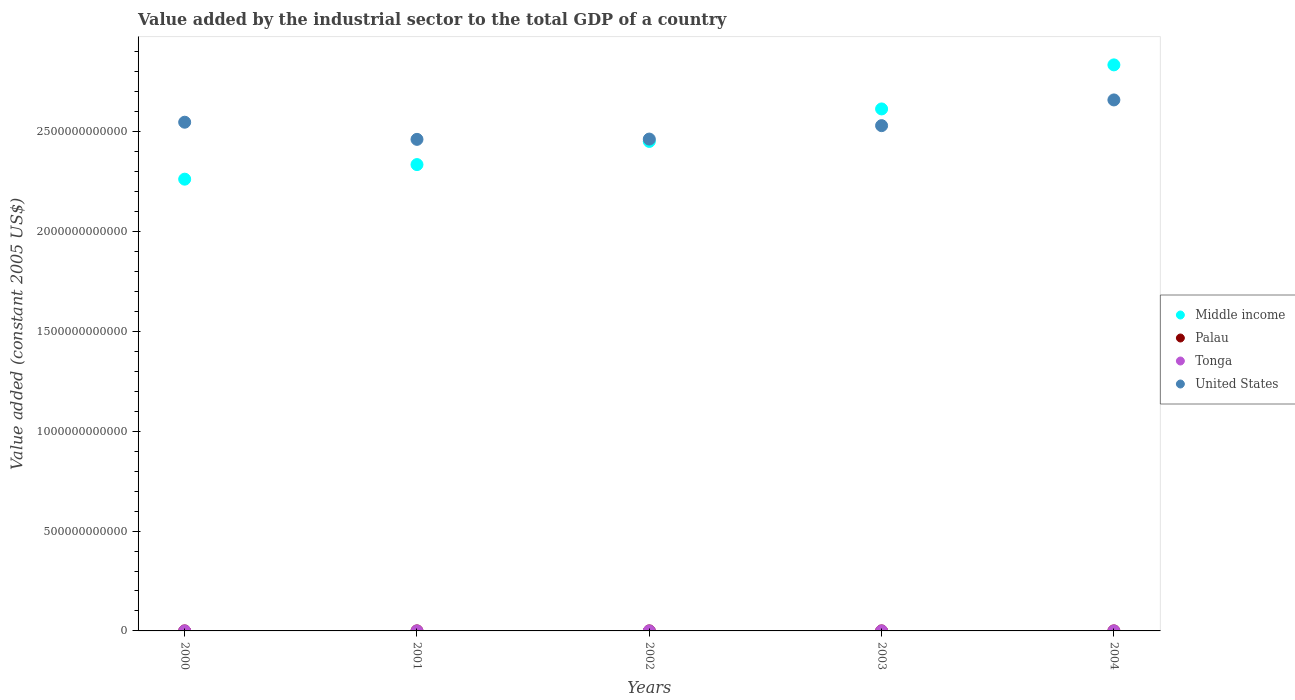How many different coloured dotlines are there?
Ensure brevity in your answer.  4. Is the number of dotlines equal to the number of legend labels?
Your answer should be very brief. Yes. What is the value added by the industrial sector in Palau in 2000?
Offer a terse response. 2.29e+07. Across all years, what is the maximum value added by the industrial sector in Middle income?
Provide a short and direct response. 2.83e+12. Across all years, what is the minimum value added by the industrial sector in Middle income?
Your answer should be compact. 2.26e+12. What is the total value added by the industrial sector in United States in the graph?
Provide a short and direct response. 1.27e+13. What is the difference between the value added by the industrial sector in Palau in 2002 and that in 2004?
Offer a terse response. 1.03e+07. What is the difference between the value added by the industrial sector in Middle income in 2003 and the value added by the industrial sector in Tonga in 2001?
Give a very brief answer. 2.61e+12. What is the average value added by the industrial sector in United States per year?
Provide a short and direct response. 2.53e+12. In the year 2001, what is the difference between the value added by the industrial sector in United States and value added by the industrial sector in Palau?
Your answer should be very brief. 2.46e+12. What is the ratio of the value added by the industrial sector in Tonga in 2001 to that in 2002?
Your answer should be compact. 0.96. Is the value added by the industrial sector in Palau in 2001 less than that in 2003?
Offer a terse response. No. What is the difference between the highest and the second highest value added by the industrial sector in Middle income?
Keep it short and to the point. 2.21e+11. What is the difference between the highest and the lowest value added by the industrial sector in Palau?
Keep it short and to the point. 1.42e+07. In how many years, is the value added by the industrial sector in Middle income greater than the average value added by the industrial sector in Middle income taken over all years?
Your answer should be very brief. 2. Is it the case that in every year, the sum of the value added by the industrial sector in United States and value added by the industrial sector in Middle income  is greater than the sum of value added by the industrial sector in Tonga and value added by the industrial sector in Palau?
Your response must be concise. Yes. Is it the case that in every year, the sum of the value added by the industrial sector in United States and value added by the industrial sector in Tonga  is greater than the value added by the industrial sector in Middle income?
Your answer should be compact. No. Does the value added by the industrial sector in United States monotonically increase over the years?
Your answer should be very brief. No. Is the value added by the industrial sector in Tonga strictly greater than the value added by the industrial sector in Palau over the years?
Offer a very short reply. Yes. Is the value added by the industrial sector in Middle income strictly less than the value added by the industrial sector in Tonga over the years?
Keep it short and to the point. No. What is the difference between two consecutive major ticks on the Y-axis?
Your response must be concise. 5.00e+11. How many legend labels are there?
Make the answer very short. 4. How are the legend labels stacked?
Provide a short and direct response. Vertical. What is the title of the graph?
Offer a very short reply. Value added by the industrial sector to the total GDP of a country. What is the label or title of the X-axis?
Provide a short and direct response. Years. What is the label or title of the Y-axis?
Offer a very short reply. Value added (constant 2005 US$). What is the Value added (constant 2005 US$) of Middle income in 2000?
Ensure brevity in your answer.  2.26e+12. What is the Value added (constant 2005 US$) of Palau in 2000?
Give a very brief answer. 2.29e+07. What is the Value added (constant 2005 US$) of Tonga in 2000?
Keep it short and to the point. 3.93e+07. What is the Value added (constant 2005 US$) in United States in 2000?
Ensure brevity in your answer.  2.55e+12. What is the Value added (constant 2005 US$) of Middle income in 2001?
Ensure brevity in your answer.  2.33e+12. What is the Value added (constant 2005 US$) of Palau in 2001?
Your response must be concise. 2.89e+07. What is the Value added (constant 2005 US$) in Tonga in 2001?
Provide a succinct answer. 4.12e+07. What is the Value added (constant 2005 US$) in United States in 2001?
Offer a very short reply. 2.46e+12. What is the Value added (constant 2005 US$) of Middle income in 2002?
Keep it short and to the point. 2.45e+12. What is the Value added (constant 2005 US$) in Palau in 2002?
Offer a terse response. 3.71e+07. What is the Value added (constant 2005 US$) in Tonga in 2002?
Your response must be concise. 4.31e+07. What is the Value added (constant 2005 US$) of United States in 2002?
Give a very brief answer. 2.46e+12. What is the Value added (constant 2005 US$) in Middle income in 2003?
Make the answer very short. 2.61e+12. What is the Value added (constant 2005 US$) of Palau in 2003?
Your answer should be compact. 2.77e+07. What is the Value added (constant 2005 US$) in Tonga in 2003?
Keep it short and to the point. 4.49e+07. What is the Value added (constant 2005 US$) in United States in 2003?
Offer a very short reply. 2.53e+12. What is the Value added (constant 2005 US$) of Middle income in 2004?
Make the answer very short. 2.83e+12. What is the Value added (constant 2005 US$) of Palau in 2004?
Your answer should be very brief. 2.68e+07. What is the Value added (constant 2005 US$) in Tonga in 2004?
Ensure brevity in your answer.  4.54e+07. What is the Value added (constant 2005 US$) in United States in 2004?
Provide a succinct answer. 2.66e+12. Across all years, what is the maximum Value added (constant 2005 US$) of Middle income?
Your response must be concise. 2.83e+12. Across all years, what is the maximum Value added (constant 2005 US$) in Palau?
Your response must be concise. 3.71e+07. Across all years, what is the maximum Value added (constant 2005 US$) of Tonga?
Offer a terse response. 4.54e+07. Across all years, what is the maximum Value added (constant 2005 US$) of United States?
Offer a terse response. 2.66e+12. Across all years, what is the minimum Value added (constant 2005 US$) of Middle income?
Make the answer very short. 2.26e+12. Across all years, what is the minimum Value added (constant 2005 US$) in Palau?
Give a very brief answer. 2.29e+07. Across all years, what is the minimum Value added (constant 2005 US$) of Tonga?
Your answer should be compact. 3.93e+07. Across all years, what is the minimum Value added (constant 2005 US$) of United States?
Ensure brevity in your answer.  2.46e+12. What is the total Value added (constant 2005 US$) in Middle income in the graph?
Give a very brief answer. 1.25e+13. What is the total Value added (constant 2005 US$) of Palau in the graph?
Ensure brevity in your answer.  1.43e+08. What is the total Value added (constant 2005 US$) of Tonga in the graph?
Give a very brief answer. 2.14e+08. What is the total Value added (constant 2005 US$) in United States in the graph?
Your answer should be compact. 1.27e+13. What is the difference between the Value added (constant 2005 US$) of Middle income in 2000 and that in 2001?
Make the answer very short. -7.30e+1. What is the difference between the Value added (constant 2005 US$) of Palau in 2000 and that in 2001?
Your answer should be compact. -5.98e+06. What is the difference between the Value added (constant 2005 US$) of Tonga in 2000 and that in 2001?
Your answer should be compact. -1.92e+06. What is the difference between the Value added (constant 2005 US$) of United States in 2000 and that in 2001?
Give a very brief answer. 8.58e+1. What is the difference between the Value added (constant 2005 US$) of Middle income in 2000 and that in 2002?
Make the answer very short. -1.89e+11. What is the difference between the Value added (constant 2005 US$) of Palau in 2000 and that in 2002?
Provide a short and direct response. -1.42e+07. What is the difference between the Value added (constant 2005 US$) of Tonga in 2000 and that in 2002?
Your answer should be very brief. -3.76e+06. What is the difference between the Value added (constant 2005 US$) of United States in 2000 and that in 2002?
Give a very brief answer. 8.44e+1. What is the difference between the Value added (constant 2005 US$) in Middle income in 2000 and that in 2003?
Your answer should be compact. -3.52e+11. What is the difference between the Value added (constant 2005 US$) in Palau in 2000 and that in 2003?
Your response must be concise. -4.77e+06. What is the difference between the Value added (constant 2005 US$) in Tonga in 2000 and that in 2003?
Your answer should be compact. -5.57e+06. What is the difference between the Value added (constant 2005 US$) in United States in 2000 and that in 2003?
Keep it short and to the point. 1.72e+1. What is the difference between the Value added (constant 2005 US$) in Middle income in 2000 and that in 2004?
Offer a terse response. -5.72e+11. What is the difference between the Value added (constant 2005 US$) of Palau in 2000 and that in 2004?
Give a very brief answer. -3.90e+06. What is the difference between the Value added (constant 2005 US$) of Tonga in 2000 and that in 2004?
Offer a very short reply. -6.11e+06. What is the difference between the Value added (constant 2005 US$) of United States in 2000 and that in 2004?
Offer a very short reply. -1.12e+11. What is the difference between the Value added (constant 2005 US$) in Middle income in 2001 and that in 2002?
Keep it short and to the point. -1.16e+11. What is the difference between the Value added (constant 2005 US$) of Palau in 2001 and that in 2002?
Your response must be concise. -8.19e+06. What is the difference between the Value added (constant 2005 US$) of Tonga in 2001 and that in 2002?
Your answer should be very brief. -1.85e+06. What is the difference between the Value added (constant 2005 US$) of United States in 2001 and that in 2002?
Provide a short and direct response. -1.44e+09. What is the difference between the Value added (constant 2005 US$) of Middle income in 2001 and that in 2003?
Provide a succinct answer. -2.79e+11. What is the difference between the Value added (constant 2005 US$) of Palau in 2001 and that in 2003?
Ensure brevity in your answer.  1.21e+06. What is the difference between the Value added (constant 2005 US$) in Tonga in 2001 and that in 2003?
Give a very brief answer. -3.65e+06. What is the difference between the Value added (constant 2005 US$) in United States in 2001 and that in 2003?
Ensure brevity in your answer.  -6.86e+1. What is the difference between the Value added (constant 2005 US$) in Middle income in 2001 and that in 2004?
Offer a very short reply. -4.99e+11. What is the difference between the Value added (constant 2005 US$) in Palau in 2001 and that in 2004?
Ensure brevity in your answer.  2.09e+06. What is the difference between the Value added (constant 2005 US$) of Tonga in 2001 and that in 2004?
Offer a terse response. -4.19e+06. What is the difference between the Value added (constant 2005 US$) in United States in 2001 and that in 2004?
Your answer should be compact. -1.97e+11. What is the difference between the Value added (constant 2005 US$) in Middle income in 2002 and that in 2003?
Your response must be concise. -1.63e+11. What is the difference between the Value added (constant 2005 US$) in Palau in 2002 and that in 2003?
Offer a very short reply. 9.40e+06. What is the difference between the Value added (constant 2005 US$) in Tonga in 2002 and that in 2003?
Provide a short and direct response. -1.81e+06. What is the difference between the Value added (constant 2005 US$) of United States in 2002 and that in 2003?
Keep it short and to the point. -6.72e+1. What is the difference between the Value added (constant 2005 US$) of Middle income in 2002 and that in 2004?
Provide a succinct answer. -3.83e+11. What is the difference between the Value added (constant 2005 US$) in Palau in 2002 and that in 2004?
Ensure brevity in your answer.  1.03e+07. What is the difference between the Value added (constant 2005 US$) of Tonga in 2002 and that in 2004?
Keep it short and to the point. -2.35e+06. What is the difference between the Value added (constant 2005 US$) of United States in 2002 and that in 2004?
Keep it short and to the point. -1.96e+11. What is the difference between the Value added (constant 2005 US$) in Middle income in 2003 and that in 2004?
Make the answer very short. -2.21e+11. What is the difference between the Value added (constant 2005 US$) of Palau in 2003 and that in 2004?
Make the answer very short. 8.75e+05. What is the difference between the Value added (constant 2005 US$) in Tonga in 2003 and that in 2004?
Make the answer very short. -5.37e+05. What is the difference between the Value added (constant 2005 US$) in United States in 2003 and that in 2004?
Your answer should be very brief. -1.29e+11. What is the difference between the Value added (constant 2005 US$) of Middle income in 2000 and the Value added (constant 2005 US$) of Palau in 2001?
Your answer should be compact. 2.26e+12. What is the difference between the Value added (constant 2005 US$) in Middle income in 2000 and the Value added (constant 2005 US$) in Tonga in 2001?
Provide a succinct answer. 2.26e+12. What is the difference between the Value added (constant 2005 US$) in Middle income in 2000 and the Value added (constant 2005 US$) in United States in 2001?
Provide a succinct answer. -1.99e+11. What is the difference between the Value added (constant 2005 US$) in Palau in 2000 and the Value added (constant 2005 US$) in Tonga in 2001?
Give a very brief answer. -1.83e+07. What is the difference between the Value added (constant 2005 US$) in Palau in 2000 and the Value added (constant 2005 US$) in United States in 2001?
Provide a succinct answer. -2.46e+12. What is the difference between the Value added (constant 2005 US$) in Tonga in 2000 and the Value added (constant 2005 US$) in United States in 2001?
Your answer should be very brief. -2.46e+12. What is the difference between the Value added (constant 2005 US$) of Middle income in 2000 and the Value added (constant 2005 US$) of Palau in 2002?
Your answer should be very brief. 2.26e+12. What is the difference between the Value added (constant 2005 US$) in Middle income in 2000 and the Value added (constant 2005 US$) in Tonga in 2002?
Provide a short and direct response. 2.26e+12. What is the difference between the Value added (constant 2005 US$) of Middle income in 2000 and the Value added (constant 2005 US$) of United States in 2002?
Your response must be concise. -2.01e+11. What is the difference between the Value added (constant 2005 US$) of Palau in 2000 and the Value added (constant 2005 US$) of Tonga in 2002?
Provide a short and direct response. -2.02e+07. What is the difference between the Value added (constant 2005 US$) in Palau in 2000 and the Value added (constant 2005 US$) in United States in 2002?
Provide a short and direct response. -2.46e+12. What is the difference between the Value added (constant 2005 US$) in Tonga in 2000 and the Value added (constant 2005 US$) in United States in 2002?
Your answer should be compact. -2.46e+12. What is the difference between the Value added (constant 2005 US$) of Middle income in 2000 and the Value added (constant 2005 US$) of Palau in 2003?
Ensure brevity in your answer.  2.26e+12. What is the difference between the Value added (constant 2005 US$) of Middle income in 2000 and the Value added (constant 2005 US$) of Tonga in 2003?
Make the answer very short. 2.26e+12. What is the difference between the Value added (constant 2005 US$) in Middle income in 2000 and the Value added (constant 2005 US$) in United States in 2003?
Ensure brevity in your answer.  -2.68e+11. What is the difference between the Value added (constant 2005 US$) of Palau in 2000 and the Value added (constant 2005 US$) of Tonga in 2003?
Your answer should be compact. -2.20e+07. What is the difference between the Value added (constant 2005 US$) of Palau in 2000 and the Value added (constant 2005 US$) of United States in 2003?
Keep it short and to the point. -2.53e+12. What is the difference between the Value added (constant 2005 US$) of Tonga in 2000 and the Value added (constant 2005 US$) of United States in 2003?
Ensure brevity in your answer.  -2.53e+12. What is the difference between the Value added (constant 2005 US$) in Middle income in 2000 and the Value added (constant 2005 US$) in Palau in 2004?
Your answer should be compact. 2.26e+12. What is the difference between the Value added (constant 2005 US$) of Middle income in 2000 and the Value added (constant 2005 US$) of Tonga in 2004?
Make the answer very short. 2.26e+12. What is the difference between the Value added (constant 2005 US$) in Middle income in 2000 and the Value added (constant 2005 US$) in United States in 2004?
Ensure brevity in your answer.  -3.97e+11. What is the difference between the Value added (constant 2005 US$) in Palau in 2000 and the Value added (constant 2005 US$) in Tonga in 2004?
Provide a succinct answer. -2.25e+07. What is the difference between the Value added (constant 2005 US$) of Palau in 2000 and the Value added (constant 2005 US$) of United States in 2004?
Your answer should be compact. -2.66e+12. What is the difference between the Value added (constant 2005 US$) of Tonga in 2000 and the Value added (constant 2005 US$) of United States in 2004?
Provide a short and direct response. -2.66e+12. What is the difference between the Value added (constant 2005 US$) of Middle income in 2001 and the Value added (constant 2005 US$) of Palau in 2002?
Your answer should be very brief. 2.33e+12. What is the difference between the Value added (constant 2005 US$) in Middle income in 2001 and the Value added (constant 2005 US$) in Tonga in 2002?
Provide a succinct answer. 2.33e+12. What is the difference between the Value added (constant 2005 US$) of Middle income in 2001 and the Value added (constant 2005 US$) of United States in 2002?
Your answer should be compact. -1.28e+11. What is the difference between the Value added (constant 2005 US$) in Palau in 2001 and the Value added (constant 2005 US$) in Tonga in 2002?
Your answer should be compact. -1.42e+07. What is the difference between the Value added (constant 2005 US$) of Palau in 2001 and the Value added (constant 2005 US$) of United States in 2002?
Keep it short and to the point. -2.46e+12. What is the difference between the Value added (constant 2005 US$) in Tonga in 2001 and the Value added (constant 2005 US$) in United States in 2002?
Provide a short and direct response. -2.46e+12. What is the difference between the Value added (constant 2005 US$) of Middle income in 2001 and the Value added (constant 2005 US$) of Palau in 2003?
Keep it short and to the point. 2.33e+12. What is the difference between the Value added (constant 2005 US$) in Middle income in 2001 and the Value added (constant 2005 US$) in Tonga in 2003?
Make the answer very short. 2.33e+12. What is the difference between the Value added (constant 2005 US$) in Middle income in 2001 and the Value added (constant 2005 US$) in United States in 2003?
Offer a very short reply. -1.95e+11. What is the difference between the Value added (constant 2005 US$) of Palau in 2001 and the Value added (constant 2005 US$) of Tonga in 2003?
Give a very brief answer. -1.60e+07. What is the difference between the Value added (constant 2005 US$) of Palau in 2001 and the Value added (constant 2005 US$) of United States in 2003?
Make the answer very short. -2.53e+12. What is the difference between the Value added (constant 2005 US$) of Tonga in 2001 and the Value added (constant 2005 US$) of United States in 2003?
Your answer should be very brief. -2.53e+12. What is the difference between the Value added (constant 2005 US$) in Middle income in 2001 and the Value added (constant 2005 US$) in Palau in 2004?
Offer a terse response. 2.33e+12. What is the difference between the Value added (constant 2005 US$) in Middle income in 2001 and the Value added (constant 2005 US$) in Tonga in 2004?
Ensure brevity in your answer.  2.33e+12. What is the difference between the Value added (constant 2005 US$) in Middle income in 2001 and the Value added (constant 2005 US$) in United States in 2004?
Provide a succinct answer. -3.24e+11. What is the difference between the Value added (constant 2005 US$) of Palau in 2001 and the Value added (constant 2005 US$) of Tonga in 2004?
Offer a very short reply. -1.65e+07. What is the difference between the Value added (constant 2005 US$) in Palau in 2001 and the Value added (constant 2005 US$) in United States in 2004?
Provide a short and direct response. -2.66e+12. What is the difference between the Value added (constant 2005 US$) in Tonga in 2001 and the Value added (constant 2005 US$) in United States in 2004?
Your answer should be very brief. -2.66e+12. What is the difference between the Value added (constant 2005 US$) in Middle income in 2002 and the Value added (constant 2005 US$) in Palau in 2003?
Provide a succinct answer. 2.45e+12. What is the difference between the Value added (constant 2005 US$) of Middle income in 2002 and the Value added (constant 2005 US$) of Tonga in 2003?
Offer a very short reply. 2.45e+12. What is the difference between the Value added (constant 2005 US$) of Middle income in 2002 and the Value added (constant 2005 US$) of United States in 2003?
Your answer should be very brief. -7.90e+1. What is the difference between the Value added (constant 2005 US$) in Palau in 2002 and the Value added (constant 2005 US$) in Tonga in 2003?
Offer a terse response. -7.81e+06. What is the difference between the Value added (constant 2005 US$) in Palau in 2002 and the Value added (constant 2005 US$) in United States in 2003?
Keep it short and to the point. -2.53e+12. What is the difference between the Value added (constant 2005 US$) in Tonga in 2002 and the Value added (constant 2005 US$) in United States in 2003?
Your answer should be compact. -2.53e+12. What is the difference between the Value added (constant 2005 US$) of Middle income in 2002 and the Value added (constant 2005 US$) of Palau in 2004?
Offer a very short reply. 2.45e+12. What is the difference between the Value added (constant 2005 US$) in Middle income in 2002 and the Value added (constant 2005 US$) in Tonga in 2004?
Your answer should be compact. 2.45e+12. What is the difference between the Value added (constant 2005 US$) in Middle income in 2002 and the Value added (constant 2005 US$) in United States in 2004?
Make the answer very short. -2.08e+11. What is the difference between the Value added (constant 2005 US$) of Palau in 2002 and the Value added (constant 2005 US$) of Tonga in 2004?
Your response must be concise. -8.35e+06. What is the difference between the Value added (constant 2005 US$) of Palau in 2002 and the Value added (constant 2005 US$) of United States in 2004?
Provide a succinct answer. -2.66e+12. What is the difference between the Value added (constant 2005 US$) in Tonga in 2002 and the Value added (constant 2005 US$) in United States in 2004?
Make the answer very short. -2.66e+12. What is the difference between the Value added (constant 2005 US$) of Middle income in 2003 and the Value added (constant 2005 US$) of Palau in 2004?
Offer a terse response. 2.61e+12. What is the difference between the Value added (constant 2005 US$) of Middle income in 2003 and the Value added (constant 2005 US$) of Tonga in 2004?
Provide a short and direct response. 2.61e+12. What is the difference between the Value added (constant 2005 US$) of Middle income in 2003 and the Value added (constant 2005 US$) of United States in 2004?
Make the answer very short. -4.51e+1. What is the difference between the Value added (constant 2005 US$) of Palau in 2003 and the Value added (constant 2005 US$) of Tonga in 2004?
Give a very brief answer. -1.77e+07. What is the difference between the Value added (constant 2005 US$) in Palau in 2003 and the Value added (constant 2005 US$) in United States in 2004?
Ensure brevity in your answer.  -2.66e+12. What is the difference between the Value added (constant 2005 US$) in Tonga in 2003 and the Value added (constant 2005 US$) in United States in 2004?
Offer a terse response. -2.66e+12. What is the average Value added (constant 2005 US$) in Middle income per year?
Provide a succinct answer. 2.50e+12. What is the average Value added (constant 2005 US$) in Palau per year?
Provide a short and direct response. 2.86e+07. What is the average Value added (constant 2005 US$) in Tonga per year?
Your answer should be compact. 4.28e+07. What is the average Value added (constant 2005 US$) of United States per year?
Make the answer very short. 2.53e+12. In the year 2000, what is the difference between the Value added (constant 2005 US$) in Middle income and Value added (constant 2005 US$) in Palau?
Offer a terse response. 2.26e+12. In the year 2000, what is the difference between the Value added (constant 2005 US$) of Middle income and Value added (constant 2005 US$) of Tonga?
Ensure brevity in your answer.  2.26e+12. In the year 2000, what is the difference between the Value added (constant 2005 US$) of Middle income and Value added (constant 2005 US$) of United States?
Give a very brief answer. -2.85e+11. In the year 2000, what is the difference between the Value added (constant 2005 US$) of Palau and Value added (constant 2005 US$) of Tonga?
Your answer should be very brief. -1.64e+07. In the year 2000, what is the difference between the Value added (constant 2005 US$) in Palau and Value added (constant 2005 US$) in United States?
Provide a short and direct response. -2.55e+12. In the year 2000, what is the difference between the Value added (constant 2005 US$) in Tonga and Value added (constant 2005 US$) in United States?
Keep it short and to the point. -2.55e+12. In the year 2001, what is the difference between the Value added (constant 2005 US$) of Middle income and Value added (constant 2005 US$) of Palau?
Provide a succinct answer. 2.33e+12. In the year 2001, what is the difference between the Value added (constant 2005 US$) of Middle income and Value added (constant 2005 US$) of Tonga?
Offer a terse response. 2.33e+12. In the year 2001, what is the difference between the Value added (constant 2005 US$) of Middle income and Value added (constant 2005 US$) of United States?
Offer a very short reply. -1.26e+11. In the year 2001, what is the difference between the Value added (constant 2005 US$) of Palau and Value added (constant 2005 US$) of Tonga?
Your response must be concise. -1.23e+07. In the year 2001, what is the difference between the Value added (constant 2005 US$) in Palau and Value added (constant 2005 US$) in United States?
Offer a very short reply. -2.46e+12. In the year 2001, what is the difference between the Value added (constant 2005 US$) of Tonga and Value added (constant 2005 US$) of United States?
Your response must be concise. -2.46e+12. In the year 2002, what is the difference between the Value added (constant 2005 US$) in Middle income and Value added (constant 2005 US$) in Palau?
Your response must be concise. 2.45e+12. In the year 2002, what is the difference between the Value added (constant 2005 US$) in Middle income and Value added (constant 2005 US$) in Tonga?
Your answer should be compact. 2.45e+12. In the year 2002, what is the difference between the Value added (constant 2005 US$) of Middle income and Value added (constant 2005 US$) of United States?
Provide a short and direct response. -1.18e+1. In the year 2002, what is the difference between the Value added (constant 2005 US$) of Palau and Value added (constant 2005 US$) of Tonga?
Your response must be concise. -6.00e+06. In the year 2002, what is the difference between the Value added (constant 2005 US$) of Palau and Value added (constant 2005 US$) of United States?
Keep it short and to the point. -2.46e+12. In the year 2002, what is the difference between the Value added (constant 2005 US$) in Tonga and Value added (constant 2005 US$) in United States?
Offer a terse response. -2.46e+12. In the year 2003, what is the difference between the Value added (constant 2005 US$) in Middle income and Value added (constant 2005 US$) in Palau?
Your answer should be compact. 2.61e+12. In the year 2003, what is the difference between the Value added (constant 2005 US$) in Middle income and Value added (constant 2005 US$) in Tonga?
Make the answer very short. 2.61e+12. In the year 2003, what is the difference between the Value added (constant 2005 US$) in Middle income and Value added (constant 2005 US$) in United States?
Provide a short and direct response. 8.37e+1. In the year 2003, what is the difference between the Value added (constant 2005 US$) in Palau and Value added (constant 2005 US$) in Tonga?
Keep it short and to the point. -1.72e+07. In the year 2003, what is the difference between the Value added (constant 2005 US$) in Palau and Value added (constant 2005 US$) in United States?
Your response must be concise. -2.53e+12. In the year 2003, what is the difference between the Value added (constant 2005 US$) in Tonga and Value added (constant 2005 US$) in United States?
Give a very brief answer. -2.53e+12. In the year 2004, what is the difference between the Value added (constant 2005 US$) in Middle income and Value added (constant 2005 US$) in Palau?
Give a very brief answer. 2.83e+12. In the year 2004, what is the difference between the Value added (constant 2005 US$) of Middle income and Value added (constant 2005 US$) of Tonga?
Your answer should be compact. 2.83e+12. In the year 2004, what is the difference between the Value added (constant 2005 US$) in Middle income and Value added (constant 2005 US$) in United States?
Make the answer very short. 1.76e+11. In the year 2004, what is the difference between the Value added (constant 2005 US$) of Palau and Value added (constant 2005 US$) of Tonga?
Your answer should be compact. -1.86e+07. In the year 2004, what is the difference between the Value added (constant 2005 US$) in Palau and Value added (constant 2005 US$) in United States?
Your response must be concise. -2.66e+12. In the year 2004, what is the difference between the Value added (constant 2005 US$) in Tonga and Value added (constant 2005 US$) in United States?
Provide a short and direct response. -2.66e+12. What is the ratio of the Value added (constant 2005 US$) of Middle income in 2000 to that in 2001?
Provide a short and direct response. 0.97. What is the ratio of the Value added (constant 2005 US$) of Palau in 2000 to that in 2001?
Provide a succinct answer. 0.79. What is the ratio of the Value added (constant 2005 US$) in Tonga in 2000 to that in 2001?
Your response must be concise. 0.95. What is the ratio of the Value added (constant 2005 US$) in United States in 2000 to that in 2001?
Provide a short and direct response. 1.03. What is the ratio of the Value added (constant 2005 US$) of Middle income in 2000 to that in 2002?
Provide a succinct answer. 0.92. What is the ratio of the Value added (constant 2005 US$) in Palau in 2000 to that in 2002?
Your response must be concise. 0.62. What is the ratio of the Value added (constant 2005 US$) in Tonga in 2000 to that in 2002?
Provide a succinct answer. 0.91. What is the ratio of the Value added (constant 2005 US$) of United States in 2000 to that in 2002?
Ensure brevity in your answer.  1.03. What is the ratio of the Value added (constant 2005 US$) of Middle income in 2000 to that in 2003?
Your answer should be compact. 0.87. What is the ratio of the Value added (constant 2005 US$) in Palau in 2000 to that in 2003?
Provide a short and direct response. 0.83. What is the ratio of the Value added (constant 2005 US$) in Tonga in 2000 to that in 2003?
Provide a succinct answer. 0.88. What is the ratio of the Value added (constant 2005 US$) in United States in 2000 to that in 2003?
Provide a short and direct response. 1.01. What is the ratio of the Value added (constant 2005 US$) in Middle income in 2000 to that in 2004?
Provide a short and direct response. 0.8. What is the ratio of the Value added (constant 2005 US$) in Palau in 2000 to that in 2004?
Ensure brevity in your answer.  0.85. What is the ratio of the Value added (constant 2005 US$) of Tonga in 2000 to that in 2004?
Give a very brief answer. 0.87. What is the ratio of the Value added (constant 2005 US$) of United States in 2000 to that in 2004?
Make the answer very short. 0.96. What is the ratio of the Value added (constant 2005 US$) of Middle income in 2001 to that in 2002?
Your answer should be very brief. 0.95. What is the ratio of the Value added (constant 2005 US$) in Palau in 2001 to that in 2002?
Offer a terse response. 0.78. What is the ratio of the Value added (constant 2005 US$) in Tonga in 2001 to that in 2002?
Ensure brevity in your answer.  0.96. What is the ratio of the Value added (constant 2005 US$) in United States in 2001 to that in 2002?
Keep it short and to the point. 1. What is the ratio of the Value added (constant 2005 US$) in Middle income in 2001 to that in 2003?
Ensure brevity in your answer.  0.89. What is the ratio of the Value added (constant 2005 US$) in Palau in 2001 to that in 2003?
Give a very brief answer. 1.04. What is the ratio of the Value added (constant 2005 US$) of Tonga in 2001 to that in 2003?
Keep it short and to the point. 0.92. What is the ratio of the Value added (constant 2005 US$) of United States in 2001 to that in 2003?
Your answer should be very brief. 0.97. What is the ratio of the Value added (constant 2005 US$) in Middle income in 2001 to that in 2004?
Give a very brief answer. 0.82. What is the ratio of the Value added (constant 2005 US$) in Palau in 2001 to that in 2004?
Provide a succinct answer. 1.08. What is the ratio of the Value added (constant 2005 US$) in Tonga in 2001 to that in 2004?
Offer a terse response. 0.91. What is the ratio of the Value added (constant 2005 US$) in United States in 2001 to that in 2004?
Give a very brief answer. 0.93. What is the ratio of the Value added (constant 2005 US$) in Middle income in 2002 to that in 2003?
Provide a succinct answer. 0.94. What is the ratio of the Value added (constant 2005 US$) in Palau in 2002 to that in 2003?
Provide a short and direct response. 1.34. What is the ratio of the Value added (constant 2005 US$) of Tonga in 2002 to that in 2003?
Your answer should be very brief. 0.96. What is the ratio of the Value added (constant 2005 US$) of United States in 2002 to that in 2003?
Your answer should be very brief. 0.97. What is the ratio of the Value added (constant 2005 US$) in Middle income in 2002 to that in 2004?
Offer a very short reply. 0.86. What is the ratio of the Value added (constant 2005 US$) of Palau in 2002 to that in 2004?
Keep it short and to the point. 1.38. What is the ratio of the Value added (constant 2005 US$) in Tonga in 2002 to that in 2004?
Your answer should be compact. 0.95. What is the ratio of the Value added (constant 2005 US$) in United States in 2002 to that in 2004?
Your answer should be compact. 0.93. What is the ratio of the Value added (constant 2005 US$) of Middle income in 2003 to that in 2004?
Your response must be concise. 0.92. What is the ratio of the Value added (constant 2005 US$) in Palau in 2003 to that in 2004?
Your answer should be very brief. 1.03. What is the ratio of the Value added (constant 2005 US$) of Tonga in 2003 to that in 2004?
Make the answer very short. 0.99. What is the ratio of the Value added (constant 2005 US$) of United States in 2003 to that in 2004?
Provide a succinct answer. 0.95. What is the difference between the highest and the second highest Value added (constant 2005 US$) in Middle income?
Provide a succinct answer. 2.21e+11. What is the difference between the highest and the second highest Value added (constant 2005 US$) in Palau?
Make the answer very short. 8.19e+06. What is the difference between the highest and the second highest Value added (constant 2005 US$) in Tonga?
Your answer should be very brief. 5.37e+05. What is the difference between the highest and the second highest Value added (constant 2005 US$) of United States?
Offer a terse response. 1.12e+11. What is the difference between the highest and the lowest Value added (constant 2005 US$) in Middle income?
Your answer should be compact. 5.72e+11. What is the difference between the highest and the lowest Value added (constant 2005 US$) of Palau?
Your response must be concise. 1.42e+07. What is the difference between the highest and the lowest Value added (constant 2005 US$) in Tonga?
Your answer should be compact. 6.11e+06. What is the difference between the highest and the lowest Value added (constant 2005 US$) of United States?
Give a very brief answer. 1.97e+11. 